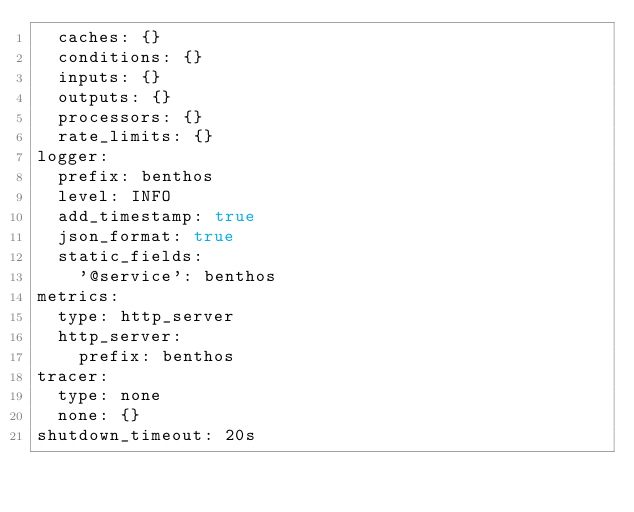Convert code to text. <code><loc_0><loc_0><loc_500><loc_500><_YAML_>  caches: {}
  conditions: {}
  inputs: {}
  outputs: {}
  processors: {}
  rate_limits: {}
logger:
  prefix: benthos
  level: INFO
  add_timestamp: true
  json_format: true
  static_fields:
    '@service': benthos
metrics:
  type: http_server
  http_server:
    prefix: benthos
tracer:
  type: none
  none: {}
shutdown_timeout: 20s
</code> 